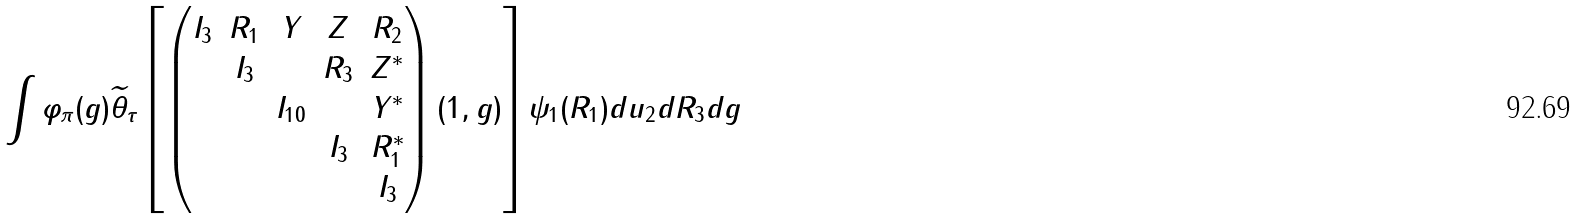Convert formula to latex. <formula><loc_0><loc_0><loc_500><loc_500>\int \varphi _ { \pi } ( g ) \widetilde { \theta } _ { \tau } \left [ \begin{pmatrix} I _ { 3 } & R _ { 1 } & Y & Z & R _ { 2 } \\ & I _ { 3 } & & R _ { 3 } & Z ^ { * } \\ & & I _ { 1 0 } & & Y ^ { * } \\ & & & I _ { 3 } & R _ { 1 } ^ { * } \\ & & & & I _ { 3 } \end{pmatrix} ( 1 , g ) \right ] \psi _ { 1 } ( R _ { 1 } ) d u _ { 2 } d R _ { 3 } d g</formula> 